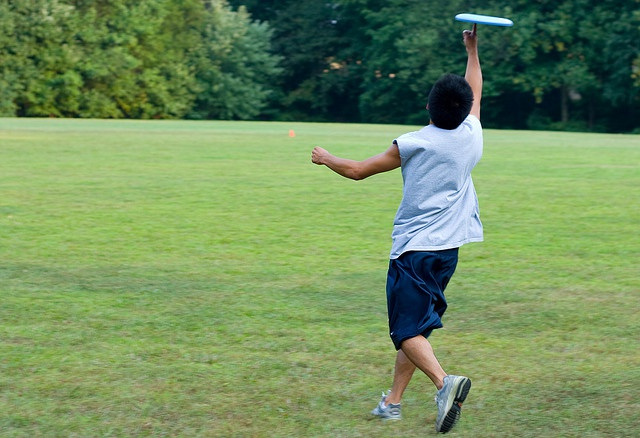Describe the objects in this image and their specific colors. I can see people in darkgreen, black, lavender, and lightblue tones and frisbee in darkgreen, lightblue, and teal tones in this image. 